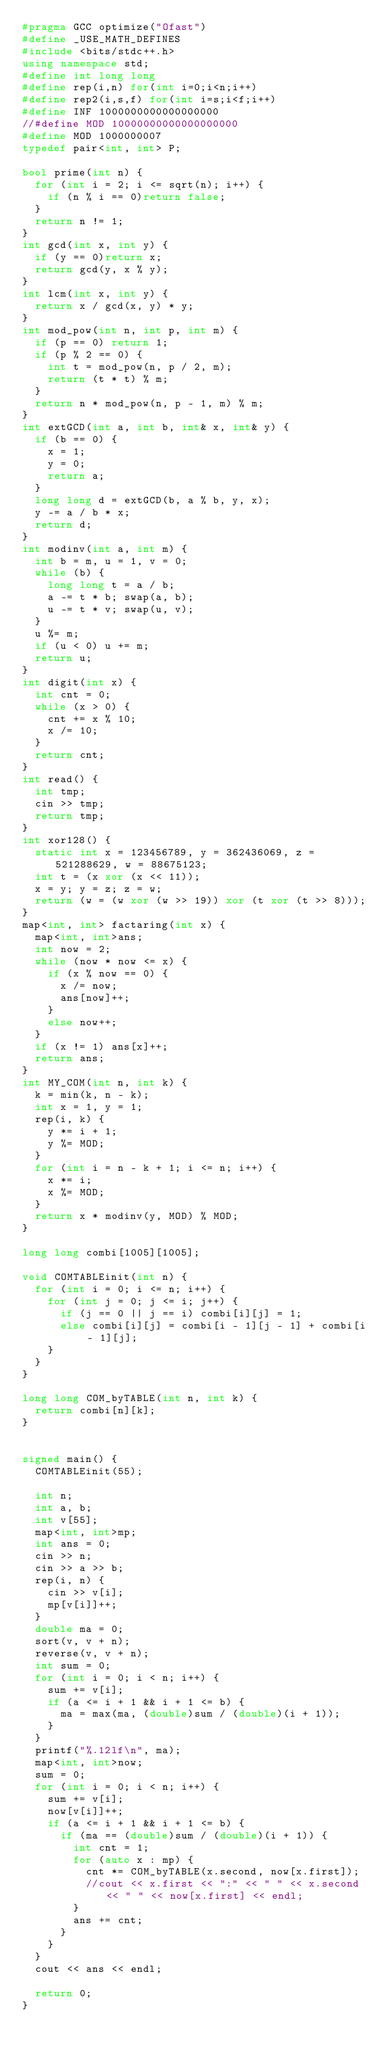Convert code to text. <code><loc_0><loc_0><loc_500><loc_500><_C++_>#pragma GCC optimize("Ofast")
#define _USE_MATH_DEFINES
#include <bits/stdc++.h>
using namespace std;
#define int long long
#define rep(i,n) for(int i=0;i<n;i++)
#define rep2(i,s,f) for(int i=s;i<f;i++)
#define INF 1000000000000000000
//#define MOD 10000000000000000000
#define MOD 1000000007
typedef pair<int, int> P;

bool prime(int n) {
	for (int i = 2; i <= sqrt(n); i++) {
		if (n % i == 0)return false;
	}
	return n != 1;
}
int gcd(int x, int y) {
	if (y == 0)return x;
	return gcd(y, x % y);
}
int lcm(int x, int y) {
	return x / gcd(x, y) * y;
}
int mod_pow(int n, int p, int m) {
	if (p == 0) return 1;
	if (p % 2 == 0) {
		int t = mod_pow(n, p / 2, m);
		return (t * t) % m;
	}
	return n * mod_pow(n, p - 1, m) % m;
}
int extGCD(int a, int b, int& x, int& y) {
	if (b == 0) {
		x = 1;
		y = 0;
		return a;
	}
	long long d = extGCD(b, a % b, y, x);
	y -= a / b * x;
	return d;
}
int modinv(int a, int m) {
	int b = m, u = 1, v = 0;
	while (b) {
		long long t = a / b;
		a -= t * b; swap(a, b);
		u -= t * v; swap(u, v);
	}
	u %= m;
	if (u < 0) u += m;
	return u;
}
int digit(int x) {
	int cnt = 0;
	while (x > 0) {
		cnt += x % 10;
		x /= 10;
	}
	return cnt;
}
int read() {
	int tmp;
	cin >> tmp;
	return tmp;
}
int xor128() {
	static int x = 123456789, y = 362436069, z = 521288629, w = 88675123;
	int t = (x xor (x << 11));
	x = y; y = z; z = w;
	return (w = (w xor (w >> 19)) xor (t xor (t >> 8)));
}
map<int, int> factaring(int x) {
	map<int, int>ans;
	int now = 2;
	while (now * now <= x) {
		if (x % now == 0) {
			x /= now;
			ans[now]++;
		}
		else now++;
	}
	if (x != 1) ans[x]++;
	return ans;
}
int MY_COM(int n, int k) {
	k = min(k, n - k);
	int x = 1, y = 1;
	rep(i, k) {
		y *= i + 1;
		y %= MOD;
	}
	for (int i = n - k + 1; i <= n; i++) {
		x *= i;
		x %= MOD;
	}
	return x * modinv(y, MOD) % MOD;
}

long long combi[1005][1005];

void COMTABLEinit(int n) {
	for (int i = 0; i <= n; i++) {
		for (int j = 0; j <= i; j++) {
			if (j == 0 || j == i) combi[i][j] = 1;
			else combi[i][j] = combi[i - 1][j - 1] + combi[i - 1][j];
		}
	}
}

long long COM_byTABLE(int n, int k) {
	return combi[n][k];
}


signed main() {
	COMTABLEinit(55);

	int n;
	int a, b;
	int v[55];
	map<int, int>mp;
	int ans = 0;
	cin >> n;
	cin >> a >> b;
	rep(i, n) {
		cin >> v[i];
		mp[v[i]]++;
	}
	double ma = 0;
	sort(v, v + n);
	reverse(v, v + n);
	int sum = 0;
	for (int i = 0; i < n; i++) {
		sum += v[i];
		if (a <= i + 1 && i + 1 <= b) {
			ma = max(ma, (double)sum / (double)(i + 1));
		}
	}
	printf("%.12lf\n", ma);
	map<int, int>now;
	sum = 0;
	for (int i = 0; i < n; i++) {
		sum += v[i];
		now[v[i]]++;
		if (a <= i + 1 && i + 1 <= b) {
			if (ma == (double)sum / (double)(i + 1)) {
				int cnt = 1;
				for (auto x : mp) {
					cnt *= COM_byTABLE(x.second, now[x.first]);
					//cout << x.first << ":" << " " << x.second << " " << now[x.first] << endl;
				}
				ans += cnt;
			}
		}
	}
	cout << ans << endl;

	return 0;
}
</code> 